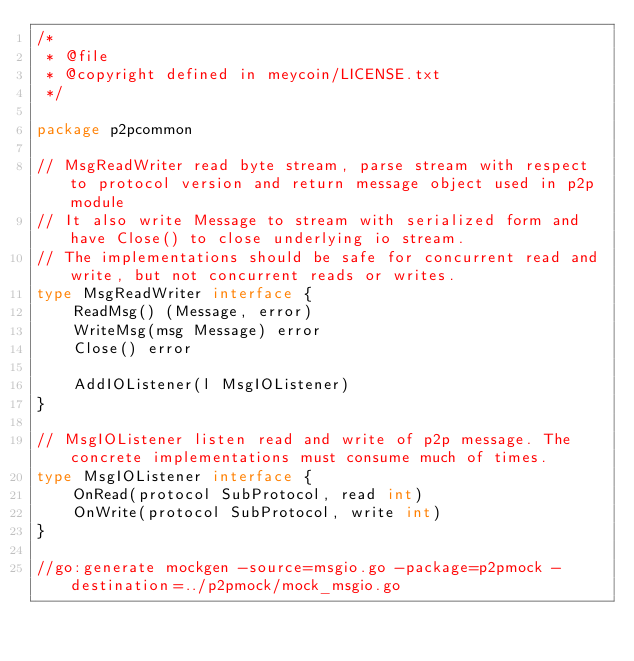Convert code to text. <code><loc_0><loc_0><loc_500><loc_500><_Go_>/*
 * @file
 * @copyright defined in meycoin/LICENSE.txt
 */

package p2pcommon

// MsgReadWriter read byte stream, parse stream with respect to protocol version and return message object used in p2p module
// It also write Message to stream with serialized form and have Close() to close underlying io stream.
// The implementations should be safe for concurrent read and write, but not concurrent reads or writes.
type MsgReadWriter interface {
	ReadMsg() (Message, error)
	WriteMsg(msg Message) error
	Close() error

	AddIOListener(l MsgIOListener)
}

// MsgIOListener listen read and write of p2p message. The concrete implementations must consume much of times.
type MsgIOListener interface {
	OnRead(protocol SubProtocol, read int)
	OnWrite(protocol SubProtocol, write int)
}

//go:generate mockgen -source=msgio.go -package=p2pmock -destination=../p2pmock/mock_msgio.go
</code> 